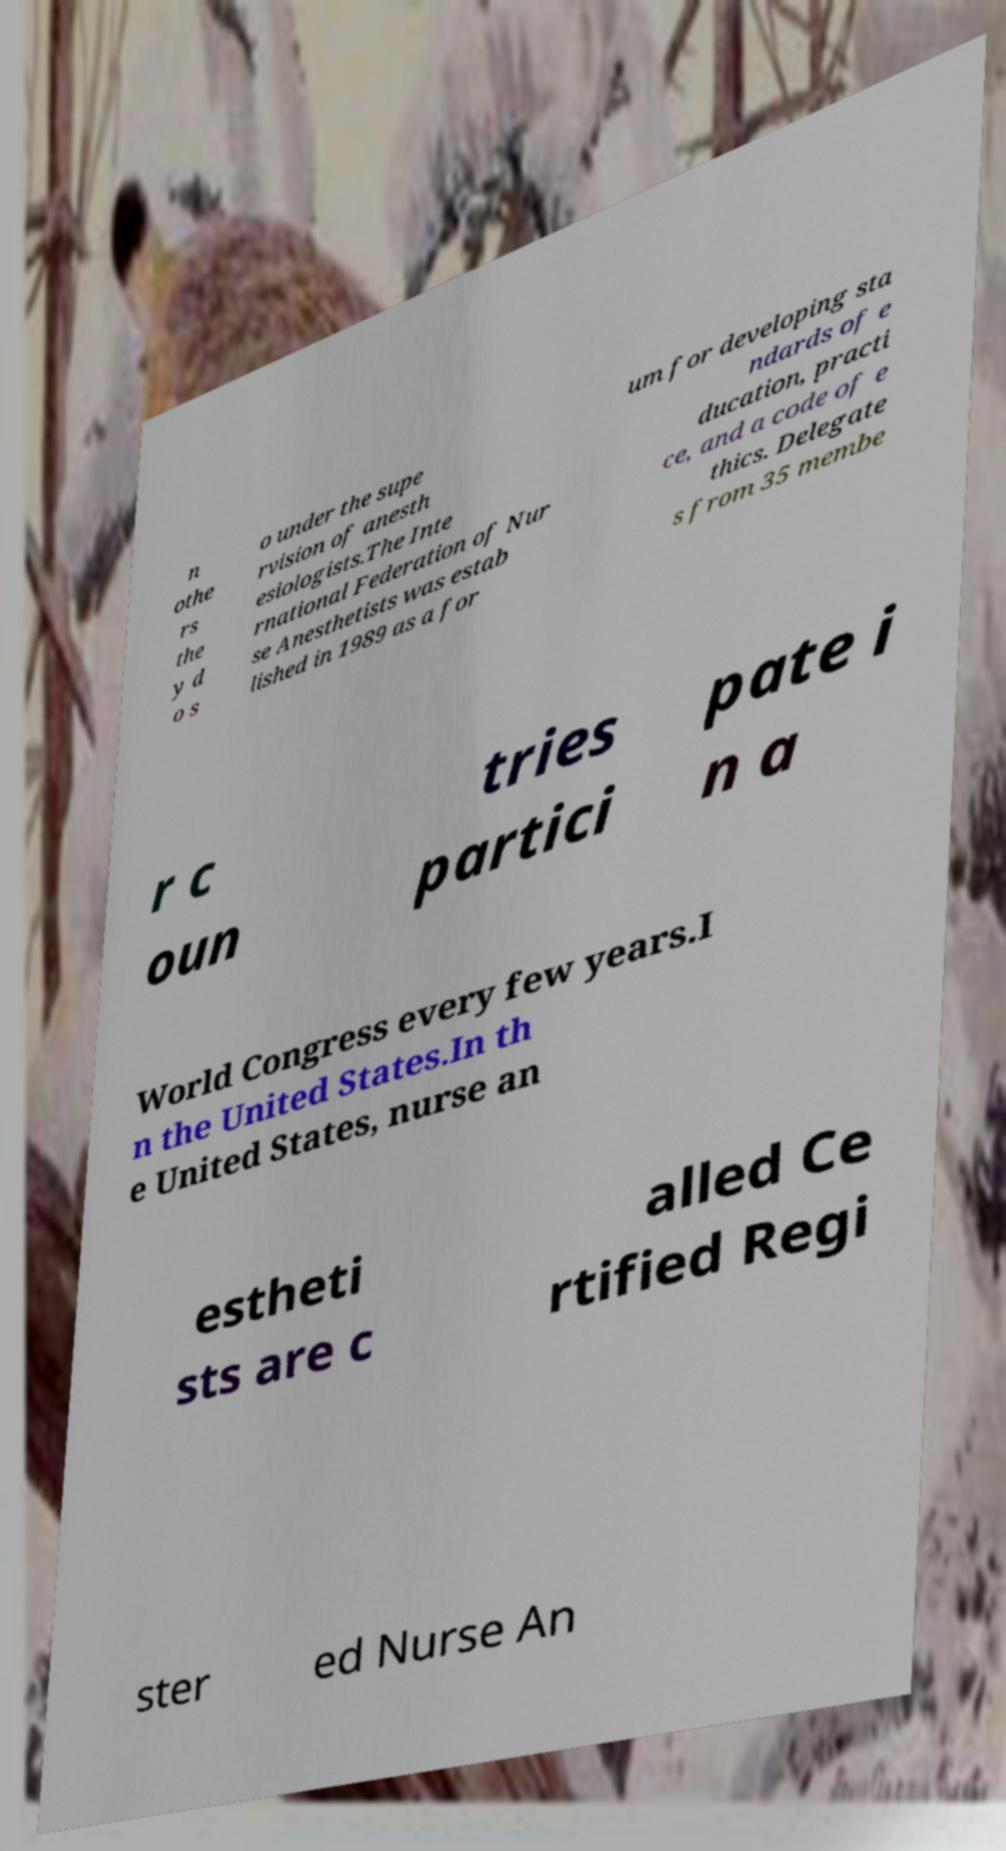I need the written content from this picture converted into text. Can you do that? n othe rs the y d o s o under the supe rvision of anesth esiologists.The Inte rnational Federation of Nur se Anesthetists was estab lished in 1989 as a for um for developing sta ndards of e ducation, practi ce, and a code of e thics. Delegate s from 35 membe r c oun tries partici pate i n a World Congress every few years.I n the United States.In th e United States, nurse an estheti sts are c alled Ce rtified Regi ster ed Nurse An 